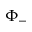<formula> <loc_0><loc_0><loc_500><loc_500>\Phi _ { - }</formula> 